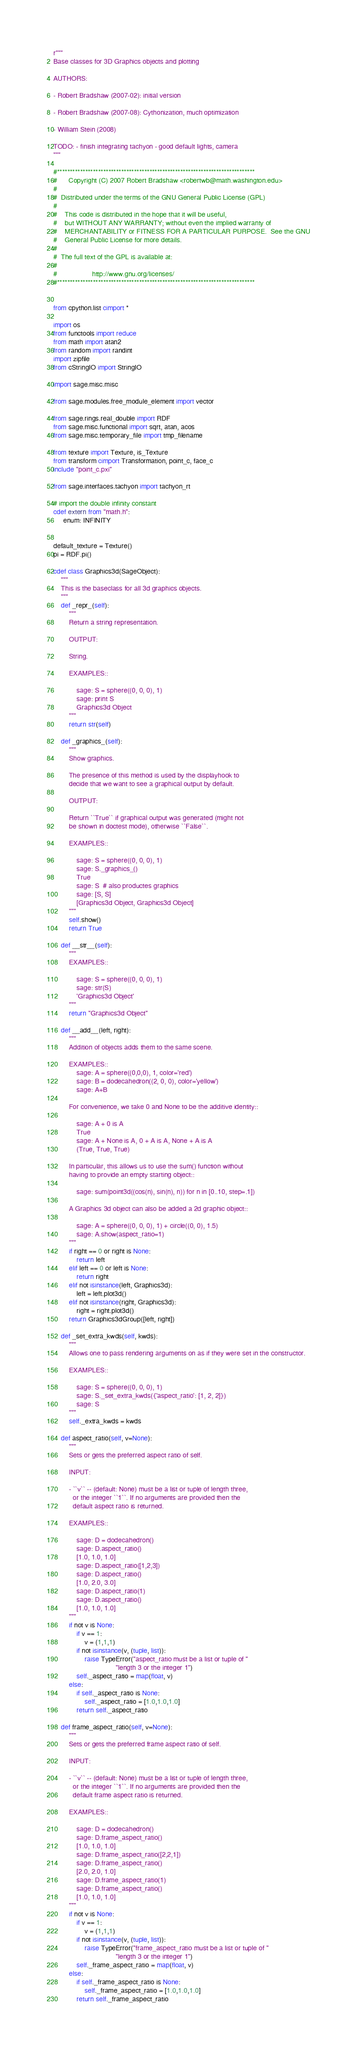<code> <loc_0><loc_0><loc_500><loc_500><_Cython_>r"""
Base classes for 3D Graphics objects and plotting

AUTHORS:

- Robert Bradshaw (2007-02): initial version

- Robert Bradshaw (2007-08): Cythonization, much optimization

- William Stein (2008)

TODO: - finish integrating tachyon - good default lights, camera
"""

#*****************************************************************************
#      Copyright (C) 2007 Robert Bradshaw <robertwb@math.washington.edu>
#
#  Distributed under the terms of the GNU General Public License (GPL)
#
#    This code is distributed in the hope that it will be useful,
#    but WITHOUT ANY WARRANTY; without even the implied warranty of
#    MERCHANTABILITY or FITNESS FOR A PARTICULAR PURPOSE.  See the GNU
#    General Public License for more details.
#
#  The full text of the GPL is available at:
#
#                  http://www.gnu.org/licenses/
#*****************************************************************************


from cpython.list cimport *

import os
from functools import reduce
from math import atan2
from random import randint
import zipfile
from cStringIO import StringIO

import sage.misc.misc

from sage.modules.free_module_element import vector

from sage.rings.real_double import RDF
from sage.misc.functional import sqrt, atan, acos
from sage.misc.temporary_file import tmp_filename

from texture import Texture, is_Texture
from transform cimport Transformation, point_c, face_c
include "point_c.pxi"

from sage.interfaces.tachyon import tachyon_rt

# import the double infinity constant
cdef extern from "math.h":
     enum: INFINITY


default_texture = Texture()
pi = RDF.pi()

cdef class Graphics3d(SageObject):
    """
    This is the baseclass for all 3d graphics objects.
    """
    def _repr_(self):
        """
        Return a string representation.

        OUTPUT:

        String.

        EXAMPLES::

            sage: S = sphere((0, 0, 0), 1)
            sage: print S
            Graphics3d Object
        """
        return str(self)

    def _graphics_(self):
        """
        Show graphics.

        The presence of this method is used by the displayhook to
        decide that we want to see a graphical output by default.

        OUTPUT:

        Return ``True`` if graphical output was generated (might not
        be shown in doctest mode), otherwise ``False``.

        EXAMPLES::

            sage: S = sphere((0, 0, 0), 1)
            sage: S._graphics_()
            True
            sage: S  # also productes graphics
            sage: [S, S]
            [Graphics3d Object, Graphics3d Object]
        """
        self.show()
        return True

    def __str__(self):
        """
        EXAMPLES::

            sage: S = sphere((0, 0, 0), 1)
            sage: str(S)
            'Graphics3d Object'
        """
        return "Graphics3d Object"

    def __add__(left, right):
        """
        Addition of objects adds them to the same scene.

        EXAMPLES::
            sage: A = sphere((0,0,0), 1, color='red')
            sage: B = dodecahedron((2, 0, 0), color='yellow')
            sage: A+B

        For convenience, we take 0 and None to be the additive identity::

            sage: A + 0 is A
            True
            sage: A + None is A, 0 + A is A, None + A is A
            (True, True, True)

        In particular, this allows us to use the sum() function without
        having to provide an empty starting object::

            sage: sum(point3d((cos(n), sin(n), n)) for n in [0..10, step=.1])

        A Graphics 3d object can also be added a 2d graphic object::

            sage: A = sphere((0, 0, 0), 1) + circle((0, 0), 1.5)
            sage: A.show(aspect_ratio=1)
        """
        if right == 0 or right is None:
            return left
        elif left == 0 or left is None:
            return right
        elif not isinstance(left, Graphics3d):
            left = left.plot3d()
        elif not isinstance(right, Graphics3d):
            right = right.plot3d()
        return Graphics3dGroup([left, right])

    def _set_extra_kwds(self, kwds):
        """
        Allows one to pass rendering arguments on as if they were set in the constructor.

        EXAMPLES::

            sage: S = sphere((0, 0, 0), 1)
            sage: S._set_extra_kwds({'aspect_ratio': [1, 2, 2]})
            sage: S
        """
        self._extra_kwds = kwds

    def aspect_ratio(self, v=None):
        """
        Sets or gets the preferred aspect ratio of self.

        INPUT:

        - ``v`` -- (default: None) must be a list or tuple of length three,
          or the integer ``1``. If no arguments are provided then the
          default aspect ratio is returned.

        EXAMPLES::

            sage: D = dodecahedron()
            sage: D.aspect_ratio()
            [1.0, 1.0, 1.0]
            sage: D.aspect_ratio([1,2,3])
            sage: D.aspect_ratio()
            [1.0, 2.0, 3.0]
            sage: D.aspect_ratio(1)
            sage: D.aspect_ratio()
            [1.0, 1.0, 1.0]
        """
        if not v is None:
            if v == 1:
                v = (1,1,1)
            if not isinstance(v, (tuple, list)):
                raise TypeError("aspect_ratio must be a list or tuple of "
                                "length 3 or the integer 1")
            self._aspect_ratio = map(float, v)
        else:
            if self._aspect_ratio is None:
                self._aspect_ratio = [1.0,1.0,1.0]
            return self._aspect_ratio

    def frame_aspect_ratio(self, v=None):
        """
        Sets or gets the preferred frame aspect ratio of self.

        INPUT:

        - ``v`` -- (default: None) must be a list or tuple of length three,
          or the integer ``1``. If no arguments are provided then the
          default frame aspect ratio is returned.

        EXAMPLES::

            sage: D = dodecahedron()
            sage: D.frame_aspect_ratio()
            [1.0, 1.0, 1.0]
            sage: D.frame_aspect_ratio([2,2,1])
            sage: D.frame_aspect_ratio()
            [2.0, 2.0, 1.0]
            sage: D.frame_aspect_ratio(1)
            sage: D.frame_aspect_ratio()
            [1.0, 1.0, 1.0]
        """
        if not v is None:
            if v == 1:
                v = (1,1,1)
            if not isinstance(v, (tuple, list)):
                raise TypeError("frame_aspect_ratio must be a list or tuple of "
                                "length 3 or the integer 1")
            self._frame_aspect_ratio = map(float, v)
        else:
            if self._frame_aspect_ratio is None:
                self._frame_aspect_ratio = [1.0,1.0,1.0]
            return self._frame_aspect_ratio
</code> 